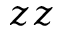<formula> <loc_0><loc_0><loc_500><loc_500>z z</formula> 